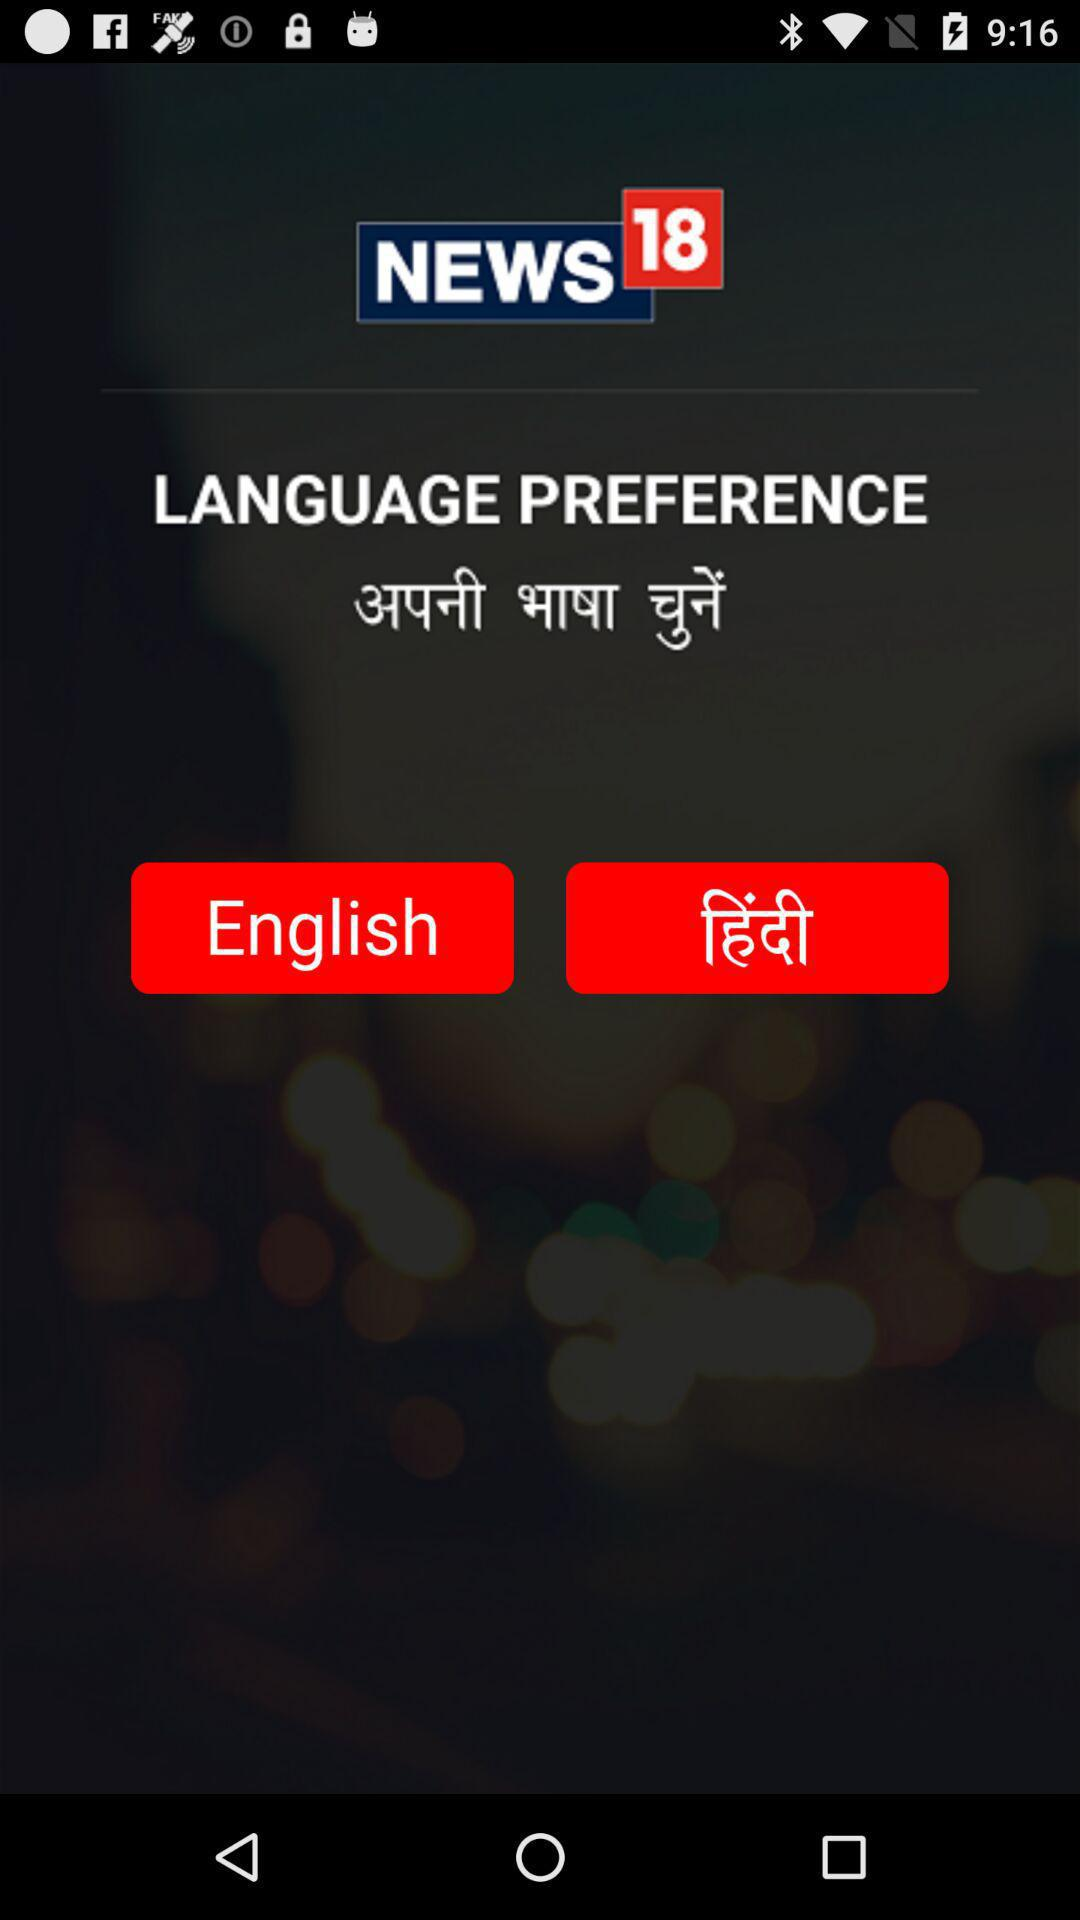How many languages are available for selection?
Answer the question using a single word or phrase. 2 